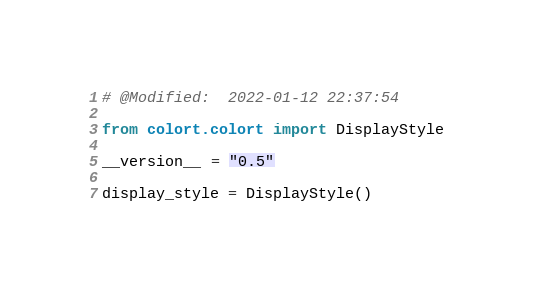<code> <loc_0><loc_0><loc_500><loc_500><_Python_># @Modified:  2022-01-12 22:37:54

from colort.colort import DisplayStyle

__version__ = "0.5"

display_style = DisplayStyle()
</code> 